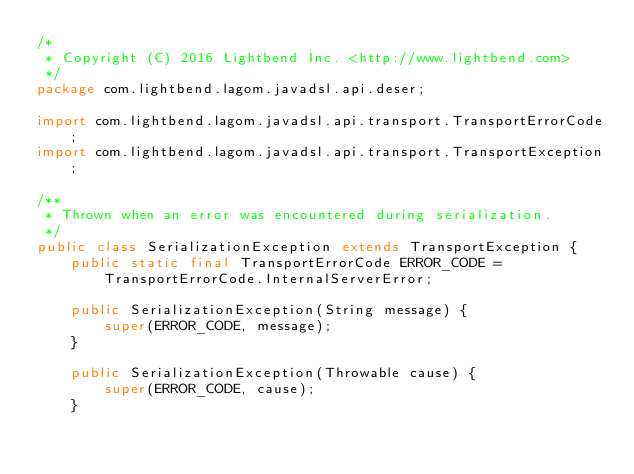Convert code to text. <code><loc_0><loc_0><loc_500><loc_500><_Java_>/*
 * Copyright (C) 2016 Lightbend Inc. <http://www.lightbend.com>
 */
package com.lightbend.lagom.javadsl.api.deser;

import com.lightbend.lagom.javadsl.api.transport.TransportErrorCode;
import com.lightbend.lagom.javadsl.api.transport.TransportException;

/**
 * Thrown when an error was encountered during serialization.
 */
public class SerializationException extends TransportException {
    public static final TransportErrorCode ERROR_CODE = TransportErrorCode.InternalServerError;

    public SerializationException(String message) {
        super(ERROR_CODE, message);
    }

    public SerializationException(Throwable cause) {
        super(ERROR_CODE, cause);
    }
</code> 